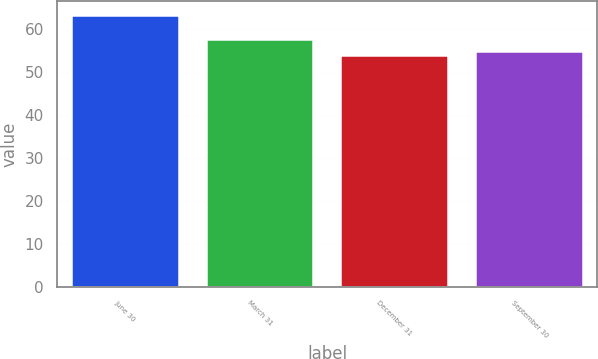Convert chart. <chart><loc_0><loc_0><loc_500><loc_500><bar_chart><fcel>June 30<fcel>March 31<fcel>December 31<fcel>September 30<nl><fcel>63.3<fcel>57.75<fcel>54.02<fcel>54.95<nl></chart> 